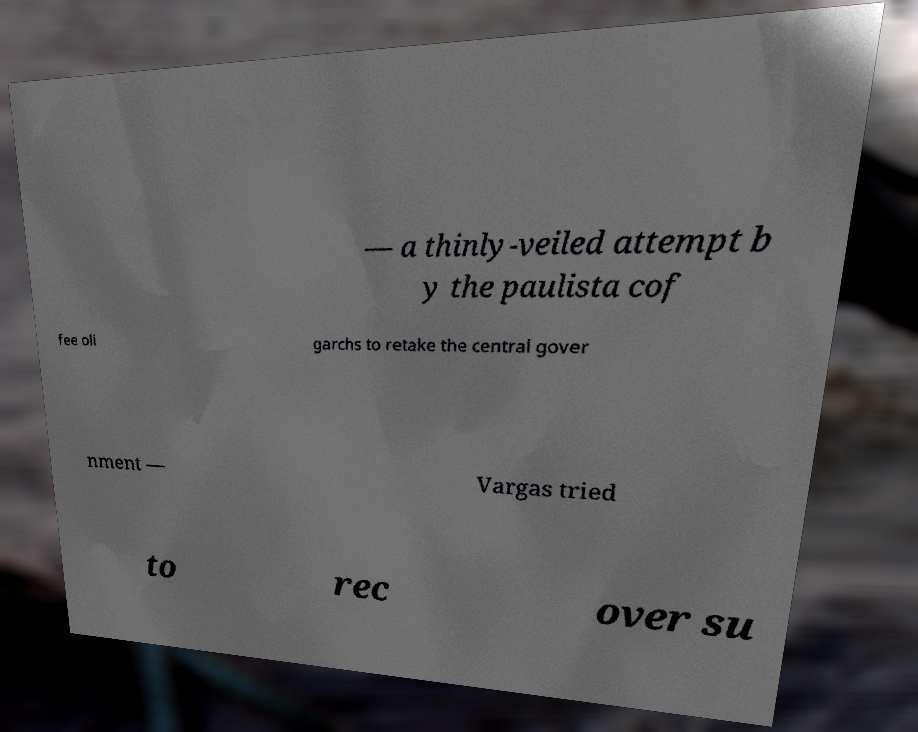What messages or text are displayed in this image? I need them in a readable, typed format. — a thinly-veiled attempt b y the paulista cof fee oli garchs to retake the central gover nment — Vargas tried to rec over su 